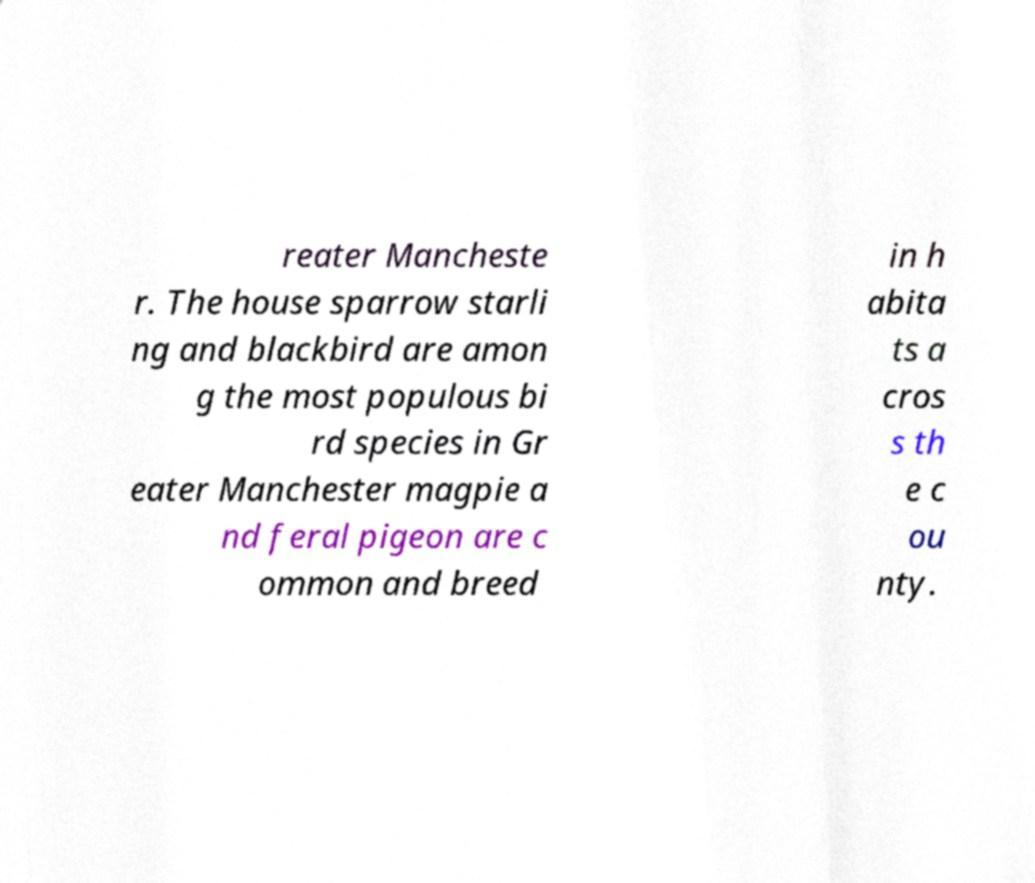What messages or text are displayed in this image? I need them in a readable, typed format. reater Mancheste r. The house sparrow starli ng and blackbird are amon g the most populous bi rd species in Gr eater Manchester magpie a nd feral pigeon are c ommon and breed in h abita ts a cros s th e c ou nty. 